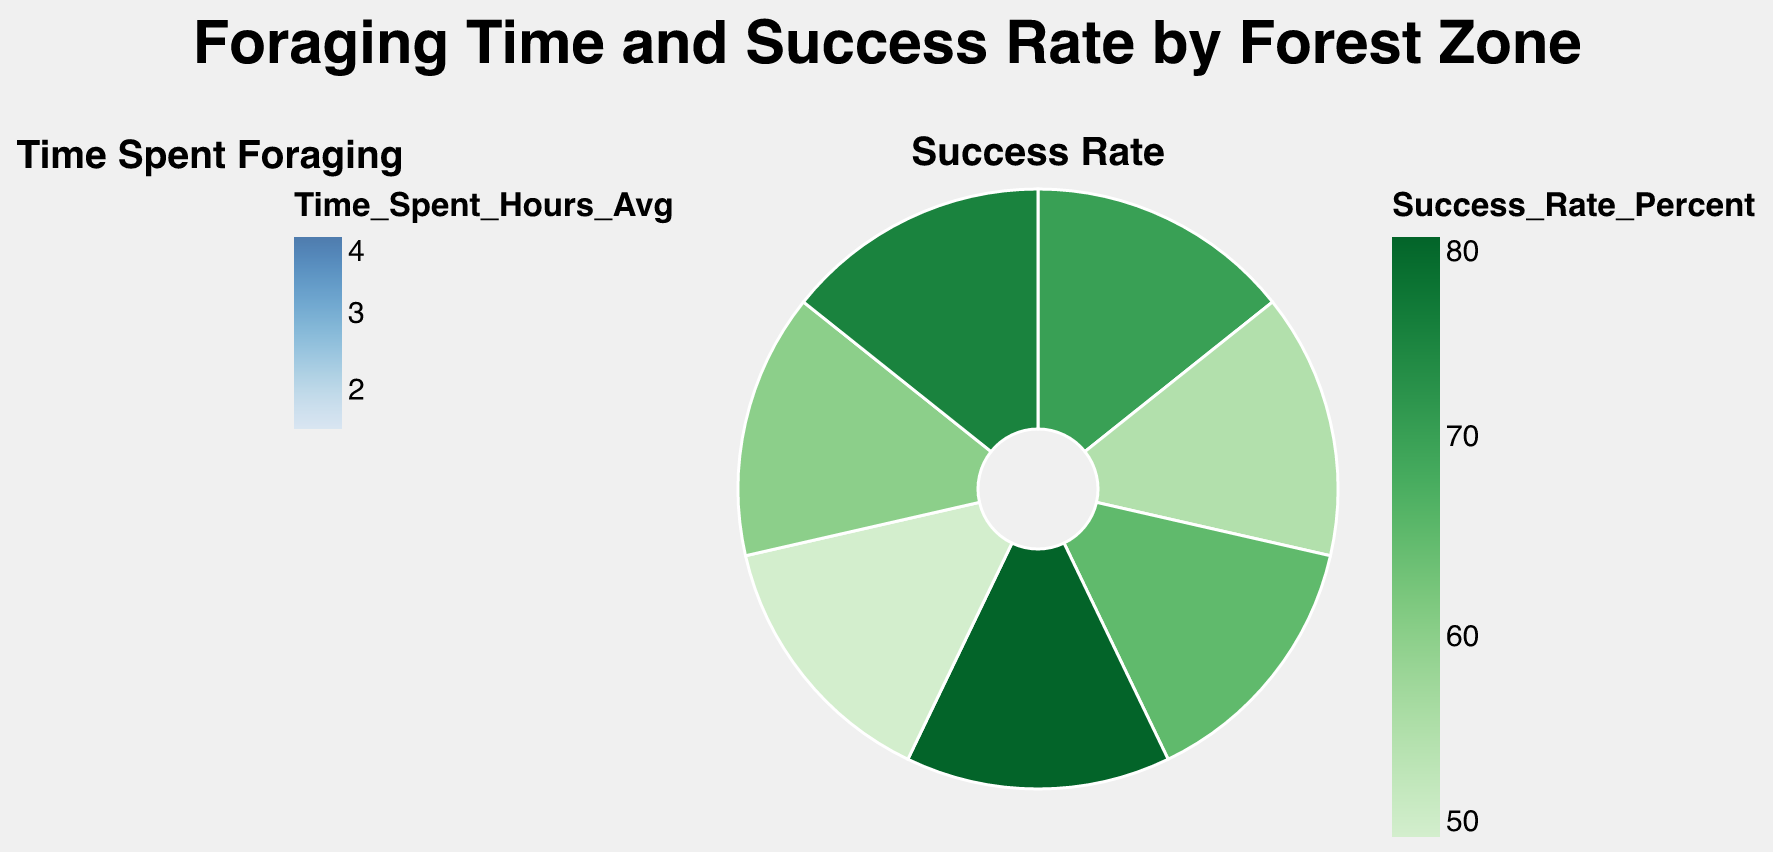How many forest zones are compared in the figure? Count the distinct forest zones in the figure. The example data shows seven different forest zones.
Answer: 7 Which forest zone has the highest success rate for foraging? Compare the arc sizes and colors in the 'Success Rate' subplot. Mixed Hardwood has the largest arc and the darkest green color, indicating the highest success rate.
Answer: Mixed Hardwood Which forest zone has the lowest time spent foraging? Examine the area sizes and colors in the 'Time Spent Foraging' subplot. Birch Woodland has the smallest area and lightest blue color, indicating the lowest time spent.
Answer: Birch Woodland What is the average success rate for foraging in the given forest zones? Add all the success rates together and divide by the number of zones. (70 + 55 + 65 + 80 + 50 + 60 + 75) / 7 = 65.
Answer: 65 Compare the time spent foraging between Spruce Thicket and Pine Forest. Which one is higher? Check the 'Time Spent Foraging' subplot and compare the areas and colors. Spruce Thicket has a larger area and a darker blue color than Pine Forest.
Answer: Spruce Thicket Is there a correlation between time spent foraging and success rate? Compare the 'Time Spent Foraging' and 'Success Rate' subplots side by side. Observe that higher foraging times (darker blues) do not consistently match higher success rates (darker greens), indicating no clear correlation.
Answer: No clear correlation Which forest zone sees a moderate time spent foraging but a high success rate? Identify zones with mid-sized areas in 'Time Spent Foraging' and high success rates in 'Success Rate.' Mixed Hardwood has a moderate foraging time but a high success rate.
Answer: Mixed Hardwood What is the total foraging time spent across all forest zones? Sum up all the foraging times. (2.0 + 3.5 + 1.5 + 2.5 + 4.0 + 3.0 + 3.5) = 20.
Answer: 20 hours Which forest zones have success rates lower than 60%? Compare the success rates in the 'Success Rate' subplot. Pine Forest and Spruce Thicket both have success rates below 60%.
Answer: Pine Forest, Spruce Thicket Does any forest zone have both the highest value in time spent foraging and the highest success rate? Compare the largest values in both subplots. The forest zones with the highest foraging time (Spruce Thicket) and highest success rate (Mixed Hardwood) are different, indicating no overlap.
Answer: No 